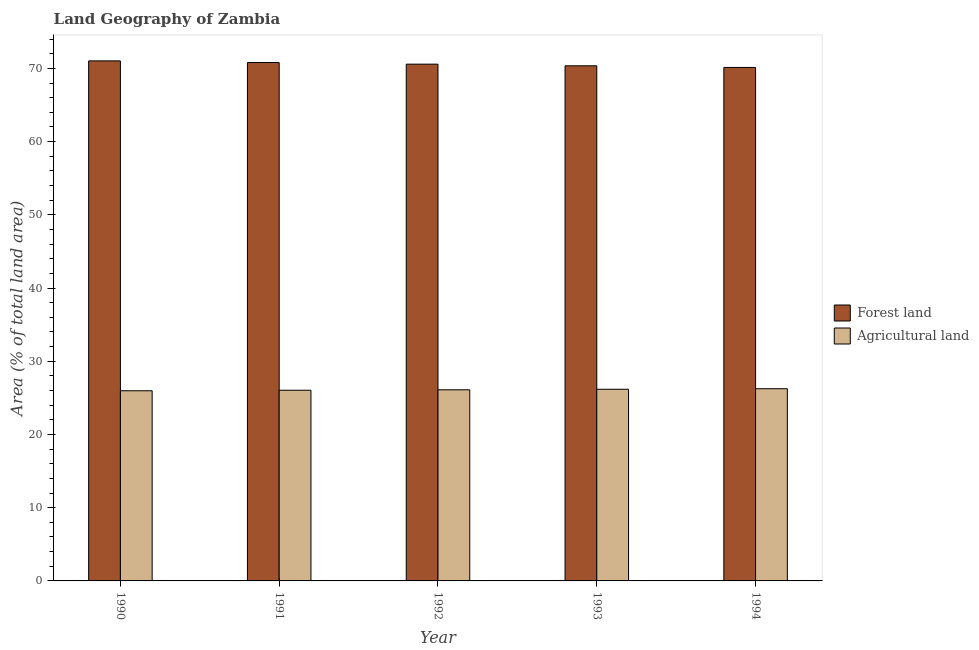How many different coloured bars are there?
Provide a succinct answer. 2. How many groups of bars are there?
Provide a succinct answer. 5. Are the number of bars per tick equal to the number of legend labels?
Ensure brevity in your answer.  Yes. Are the number of bars on each tick of the X-axis equal?
Your answer should be very brief. Yes. How many bars are there on the 5th tick from the right?
Provide a short and direct response. 2. What is the label of the 1st group of bars from the left?
Your answer should be compact. 1990. What is the percentage of land area under agriculture in 1990?
Ensure brevity in your answer.  25.97. Across all years, what is the maximum percentage of land area under agriculture?
Offer a very short reply. 26.25. Across all years, what is the minimum percentage of land area under forests?
Your answer should be compact. 70.13. In which year was the percentage of land area under agriculture maximum?
Your answer should be very brief. 1994. In which year was the percentage of land area under forests minimum?
Keep it short and to the point. 1994. What is the total percentage of land area under forests in the graph?
Offer a very short reply. 352.89. What is the difference between the percentage of land area under forests in 1991 and that in 1994?
Provide a short and direct response. 0.67. What is the difference between the percentage of land area under agriculture in 1994 and the percentage of land area under forests in 1993?
Your response must be concise. 0.07. What is the average percentage of land area under forests per year?
Provide a short and direct response. 70.58. In the year 1992, what is the difference between the percentage of land area under agriculture and percentage of land area under forests?
Provide a short and direct response. 0. In how many years, is the percentage of land area under forests greater than 40 %?
Keep it short and to the point. 5. What is the ratio of the percentage of land area under agriculture in 1990 to that in 1991?
Make the answer very short. 1. Is the percentage of land area under agriculture in 1992 less than that in 1994?
Give a very brief answer. Yes. What is the difference between the highest and the second highest percentage of land area under agriculture?
Offer a terse response. 0.07. What is the difference between the highest and the lowest percentage of land area under forests?
Provide a short and direct response. 0.9. Is the sum of the percentage of land area under agriculture in 1991 and 1992 greater than the maximum percentage of land area under forests across all years?
Your response must be concise. Yes. What does the 1st bar from the left in 1990 represents?
Offer a very short reply. Forest land. What does the 1st bar from the right in 1994 represents?
Offer a terse response. Agricultural land. What is the difference between two consecutive major ticks on the Y-axis?
Offer a terse response. 10. Are the values on the major ticks of Y-axis written in scientific E-notation?
Offer a very short reply. No. Does the graph contain any zero values?
Ensure brevity in your answer.  No. Does the graph contain grids?
Your response must be concise. No. How many legend labels are there?
Your answer should be very brief. 2. How are the legend labels stacked?
Ensure brevity in your answer.  Vertical. What is the title of the graph?
Offer a very short reply. Land Geography of Zambia. What is the label or title of the Y-axis?
Your response must be concise. Area (% of total land area). What is the Area (% of total land area) of Forest land in 1990?
Give a very brief answer. 71.03. What is the Area (% of total land area) in Agricultural land in 1990?
Ensure brevity in your answer.  25.97. What is the Area (% of total land area) of Forest land in 1991?
Your response must be concise. 70.8. What is the Area (% of total land area) in Agricultural land in 1991?
Your answer should be very brief. 26.04. What is the Area (% of total land area) in Forest land in 1992?
Your response must be concise. 70.58. What is the Area (% of total land area) in Agricultural land in 1992?
Make the answer very short. 26.1. What is the Area (% of total land area) of Forest land in 1993?
Your answer should be very brief. 70.35. What is the Area (% of total land area) in Agricultural land in 1993?
Your answer should be very brief. 26.18. What is the Area (% of total land area) of Forest land in 1994?
Provide a succinct answer. 70.13. What is the Area (% of total land area) of Agricultural land in 1994?
Your response must be concise. 26.25. Across all years, what is the maximum Area (% of total land area) in Forest land?
Ensure brevity in your answer.  71.03. Across all years, what is the maximum Area (% of total land area) in Agricultural land?
Keep it short and to the point. 26.25. Across all years, what is the minimum Area (% of total land area) in Forest land?
Offer a very short reply. 70.13. Across all years, what is the minimum Area (% of total land area) in Agricultural land?
Provide a short and direct response. 25.97. What is the total Area (% of total land area) of Forest land in the graph?
Offer a very short reply. 352.89. What is the total Area (% of total land area) in Agricultural land in the graph?
Ensure brevity in your answer.  130.54. What is the difference between the Area (% of total land area) in Forest land in 1990 and that in 1991?
Provide a short and direct response. 0.22. What is the difference between the Area (% of total land area) in Agricultural land in 1990 and that in 1991?
Your answer should be very brief. -0.07. What is the difference between the Area (% of total land area) of Forest land in 1990 and that in 1992?
Offer a very short reply. 0.45. What is the difference between the Area (% of total land area) in Agricultural land in 1990 and that in 1992?
Your response must be concise. -0.13. What is the difference between the Area (% of total land area) of Forest land in 1990 and that in 1993?
Offer a very short reply. 0.67. What is the difference between the Area (% of total land area) of Agricultural land in 1990 and that in 1993?
Offer a terse response. -0.2. What is the difference between the Area (% of total land area) in Forest land in 1990 and that in 1994?
Provide a succinct answer. 0.9. What is the difference between the Area (% of total land area) in Agricultural land in 1990 and that in 1994?
Give a very brief answer. -0.28. What is the difference between the Area (% of total land area) in Forest land in 1991 and that in 1992?
Your answer should be compact. 0.22. What is the difference between the Area (% of total land area) in Agricultural land in 1991 and that in 1992?
Offer a terse response. -0.06. What is the difference between the Area (% of total land area) of Forest land in 1991 and that in 1993?
Provide a short and direct response. 0.45. What is the difference between the Area (% of total land area) in Agricultural land in 1991 and that in 1993?
Provide a short and direct response. -0.13. What is the difference between the Area (% of total land area) of Forest land in 1991 and that in 1994?
Make the answer very short. 0.67. What is the difference between the Area (% of total land area) in Agricultural land in 1991 and that in 1994?
Your answer should be very brief. -0.21. What is the difference between the Area (% of total land area) of Forest land in 1992 and that in 1993?
Make the answer very short. 0.22. What is the difference between the Area (% of total land area) of Agricultural land in 1992 and that in 1993?
Provide a succinct answer. -0.07. What is the difference between the Area (% of total land area) of Forest land in 1992 and that in 1994?
Offer a very short reply. 0.45. What is the difference between the Area (% of total land area) in Agricultural land in 1992 and that in 1994?
Ensure brevity in your answer.  -0.15. What is the difference between the Area (% of total land area) in Forest land in 1993 and that in 1994?
Ensure brevity in your answer.  0.22. What is the difference between the Area (% of total land area) in Agricultural land in 1993 and that in 1994?
Give a very brief answer. -0.07. What is the difference between the Area (% of total land area) in Forest land in 1990 and the Area (% of total land area) in Agricultural land in 1991?
Make the answer very short. 44.98. What is the difference between the Area (% of total land area) of Forest land in 1990 and the Area (% of total land area) of Agricultural land in 1992?
Your answer should be very brief. 44.92. What is the difference between the Area (% of total land area) of Forest land in 1990 and the Area (% of total land area) of Agricultural land in 1993?
Give a very brief answer. 44.85. What is the difference between the Area (% of total land area) of Forest land in 1990 and the Area (% of total land area) of Agricultural land in 1994?
Offer a terse response. 44.78. What is the difference between the Area (% of total land area) in Forest land in 1991 and the Area (% of total land area) in Agricultural land in 1992?
Give a very brief answer. 44.7. What is the difference between the Area (% of total land area) of Forest land in 1991 and the Area (% of total land area) of Agricultural land in 1993?
Keep it short and to the point. 44.63. What is the difference between the Area (% of total land area) in Forest land in 1991 and the Area (% of total land area) in Agricultural land in 1994?
Ensure brevity in your answer.  44.55. What is the difference between the Area (% of total land area) of Forest land in 1992 and the Area (% of total land area) of Agricultural land in 1993?
Your response must be concise. 44.4. What is the difference between the Area (% of total land area) in Forest land in 1992 and the Area (% of total land area) in Agricultural land in 1994?
Give a very brief answer. 44.33. What is the difference between the Area (% of total land area) of Forest land in 1993 and the Area (% of total land area) of Agricultural land in 1994?
Your response must be concise. 44.1. What is the average Area (% of total land area) in Forest land per year?
Your answer should be compact. 70.58. What is the average Area (% of total land area) in Agricultural land per year?
Offer a terse response. 26.11. In the year 1990, what is the difference between the Area (% of total land area) in Forest land and Area (% of total land area) in Agricultural land?
Provide a succinct answer. 45.05. In the year 1991, what is the difference between the Area (% of total land area) of Forest land and Area (% of total land area) of Agricultural land?
Offer a very short reply. 44.76. In the year 1992, what is the difference between the Area (% of total land area) in Forest land and Area (% of total land area) in Agricultural land?
Ensure brevity in your answer.  44.48. In the year 1993, what is the difference between the Area (% of total land area) of Forest land and Area (% of total land area) of Agricultural land?
Your answer should be very brief. 44.18. In the year 1994, what is the difference between the Area (% of total land area) in Forest land and Area (% of total land area) in Agricultural land?
Give a very brief answer. 43.88. What is the ratio of the Area (% of total land area) in Forest land in 1990 to that in 1992?
Ensure brevity in your answer.  1.01. What is the ratio of the Area (% of total land area) of Agricultural land in 1990 to that in 1992?
Give a very brief answer. 0.99. What is the ratio of the Area (% of total land area) in Forest land in 1990 to that in 1993?
Keep it short and to the point. 1.01. What is the ratio of the Area (% of total land area) of Agricultural land in 1990 to that in 1993?
Provide a succinct answer. 0.99. What is the ratio of the Area (% of total land area) of Forest land in 1990 to that in 1994?
Offer a terse response. 1.01. What is the ratio of the Area (% of total land area) of Agricultural land in 1990 to that in 1994?
Make the answer very short. 0.99. What is the ratio of the Area (% of total land area) in Forest land in 1991 to that in 1992?
Provide a succinct answer. 1. What is the ratio of the Area (% of total land area) of Forest land in 1991 to that in 1993?
Your answer should be very brief. 1.01. What is the ratio of the Area (% of total land area) in Agricultural land in 1991 to that in 1993?
Ensure brevity in your answer.  0.99. What is the ratio of the Area (% of total land area) of Forest land in 1991 to that in 1994?
Your answer should be very brief. 1.01. What is the ratio of the Area (% of total land area) in Agricultural land in 1992 to that in 1993?
Give a very brief answer. 1. What is the ratio of the Area (% of total land area) of Forest land in 1992 to that in 1994?
Make the answer very short. 1.01. What is the ratio of the Area (% of total land area) of Agricultural land in 1992 to that in 1994?
Your answer should be very brief. 0.99. What is the difference between the highest and the second highest Area (% of total land area) in Forest land?
Provide a succinct answer. 0.22. What is the difference between the highest and the second highest Area (% of total land area) in Agricultural land?
Your answer should be very brief. 0.07. What is the difference between the highest and the lowest Area (% of total land area) in Forest land?
Give a very brief answer. 0.9. What is the difference between the highest and the lowest Area (% of total land area) in Agricultural land?
Offer a terse response. 0.28. 